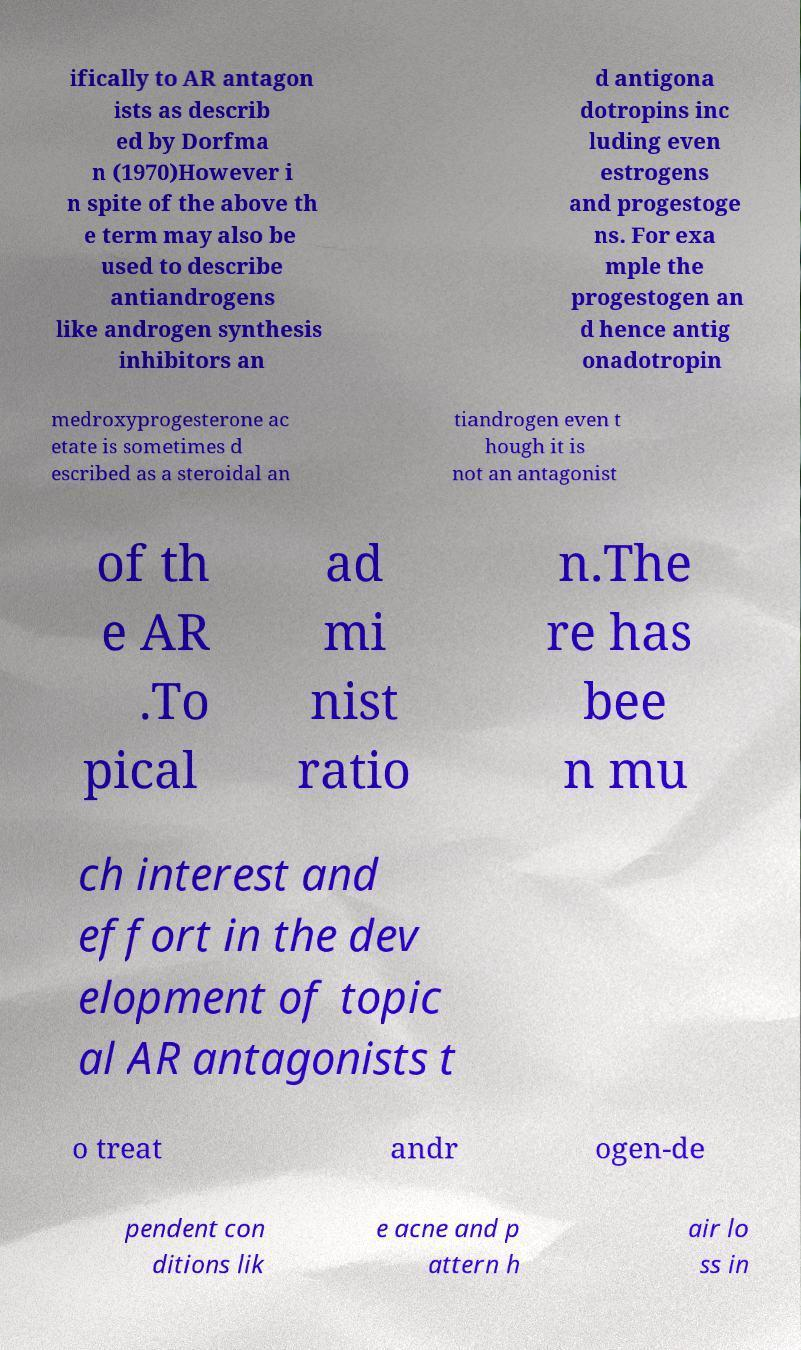I need the written content from this picture converted into text. Can you do that? ifically to AR antagon ists as describ ed by Dorfma n (1970)However i n spite of the above th e term may also be used to describe antiandrogens like androgen synthesis inhibitors an d antigona dotropins inc luding even estrogens and progestoge ns. For exa mple the progestogen an d hence antig onadotropin medroxyprogesterone ac etate is sometimes d escribed as a steroidal an tiandrogen even t hough it is not an antagonist of th e AR .To pical ad mi nist ratio n.The re has bee n mu ch interest and effort in the dev elopment of topic al AR antagonists t o treat andr ogen-de pendent con ditions lik e acne and p attern h air lo ss in 